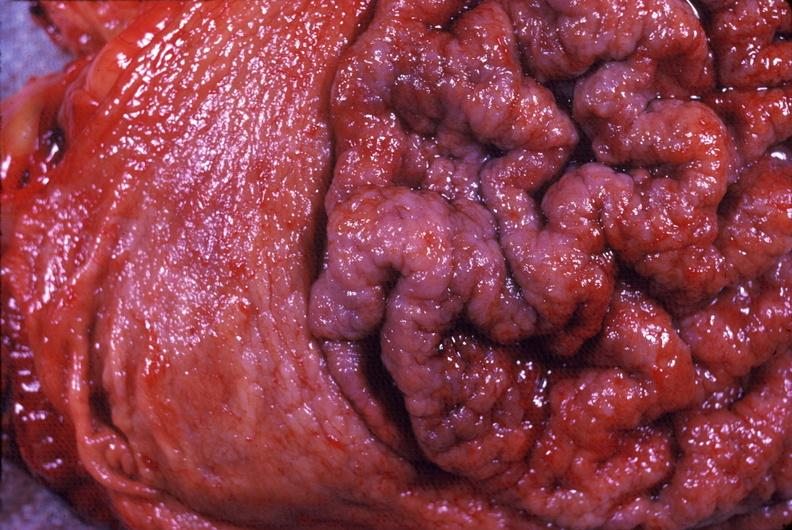where does this belong to?
Answer the question using a single word or phrase. Gastrointestinal system 